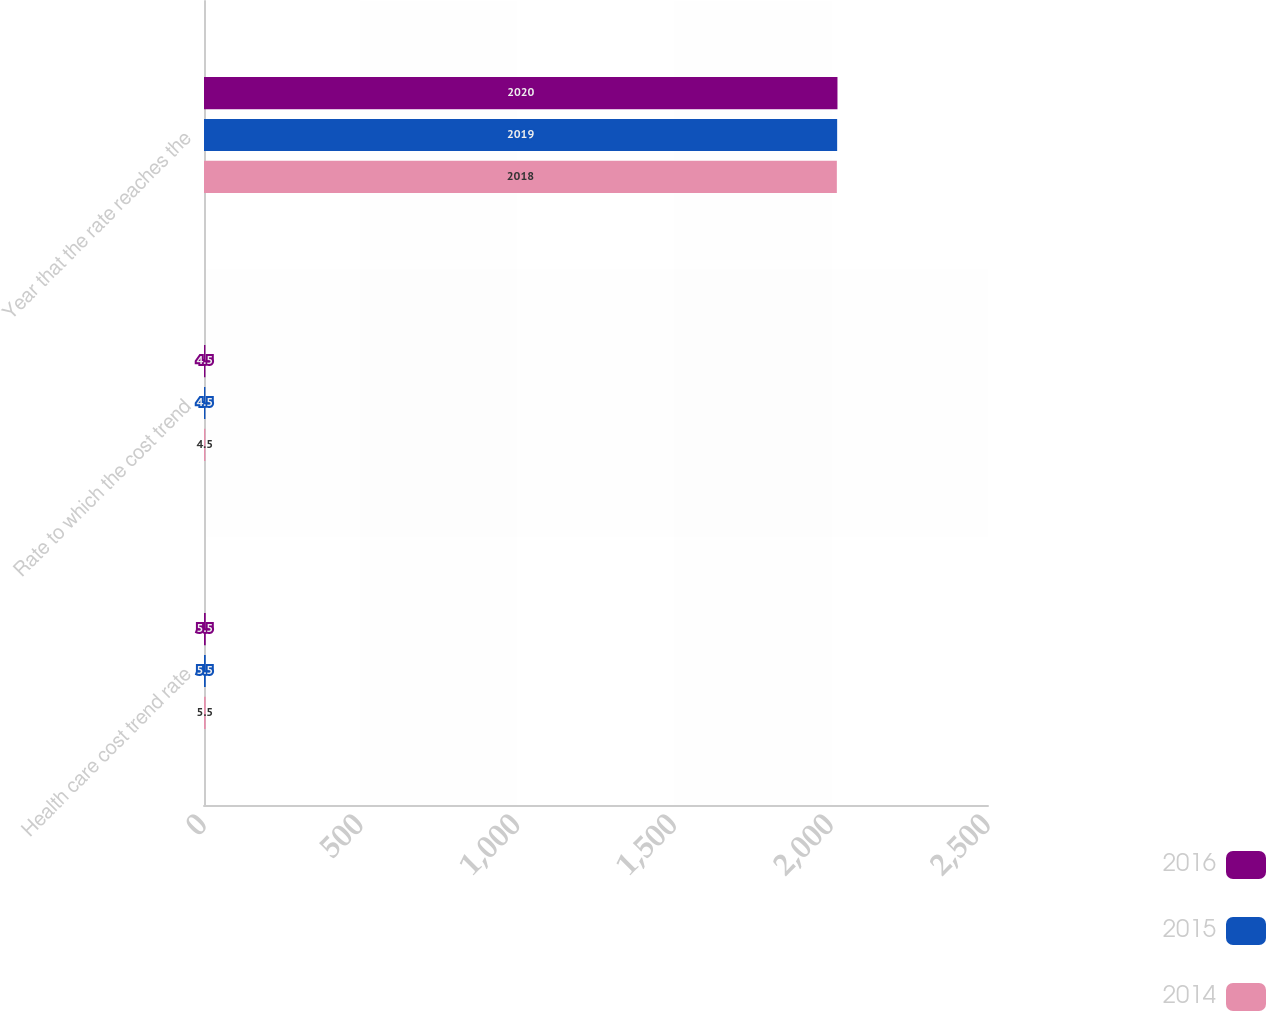Convert chart. <chart><loc_0><loc_0><loc_500><loc_500><stacked_bar_chart><ecel><fcel>Health care cost trend rate<fcel>Rate to which the cost trend<fcel>Year that the rate reaches the<nl><fcel>2016<fcel>5.5<fcel>4.5<fcel>2020<nl><fcel>2015<fcel>5.5<fcel>4.5<fcel>2019<nl><fcel>2014<fcel>5.5<fcel>4.5<fcel>2018<nl></chart> 